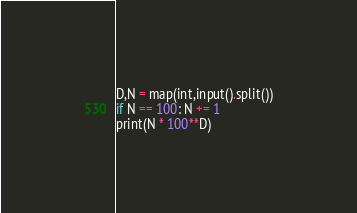Convert code to text. <code><loc_0><loc_0><loc_500><loc_500><_Python_>D,N = map(int,input().split())
if N == 100: N += 1
print(N * 100**D)</code> 